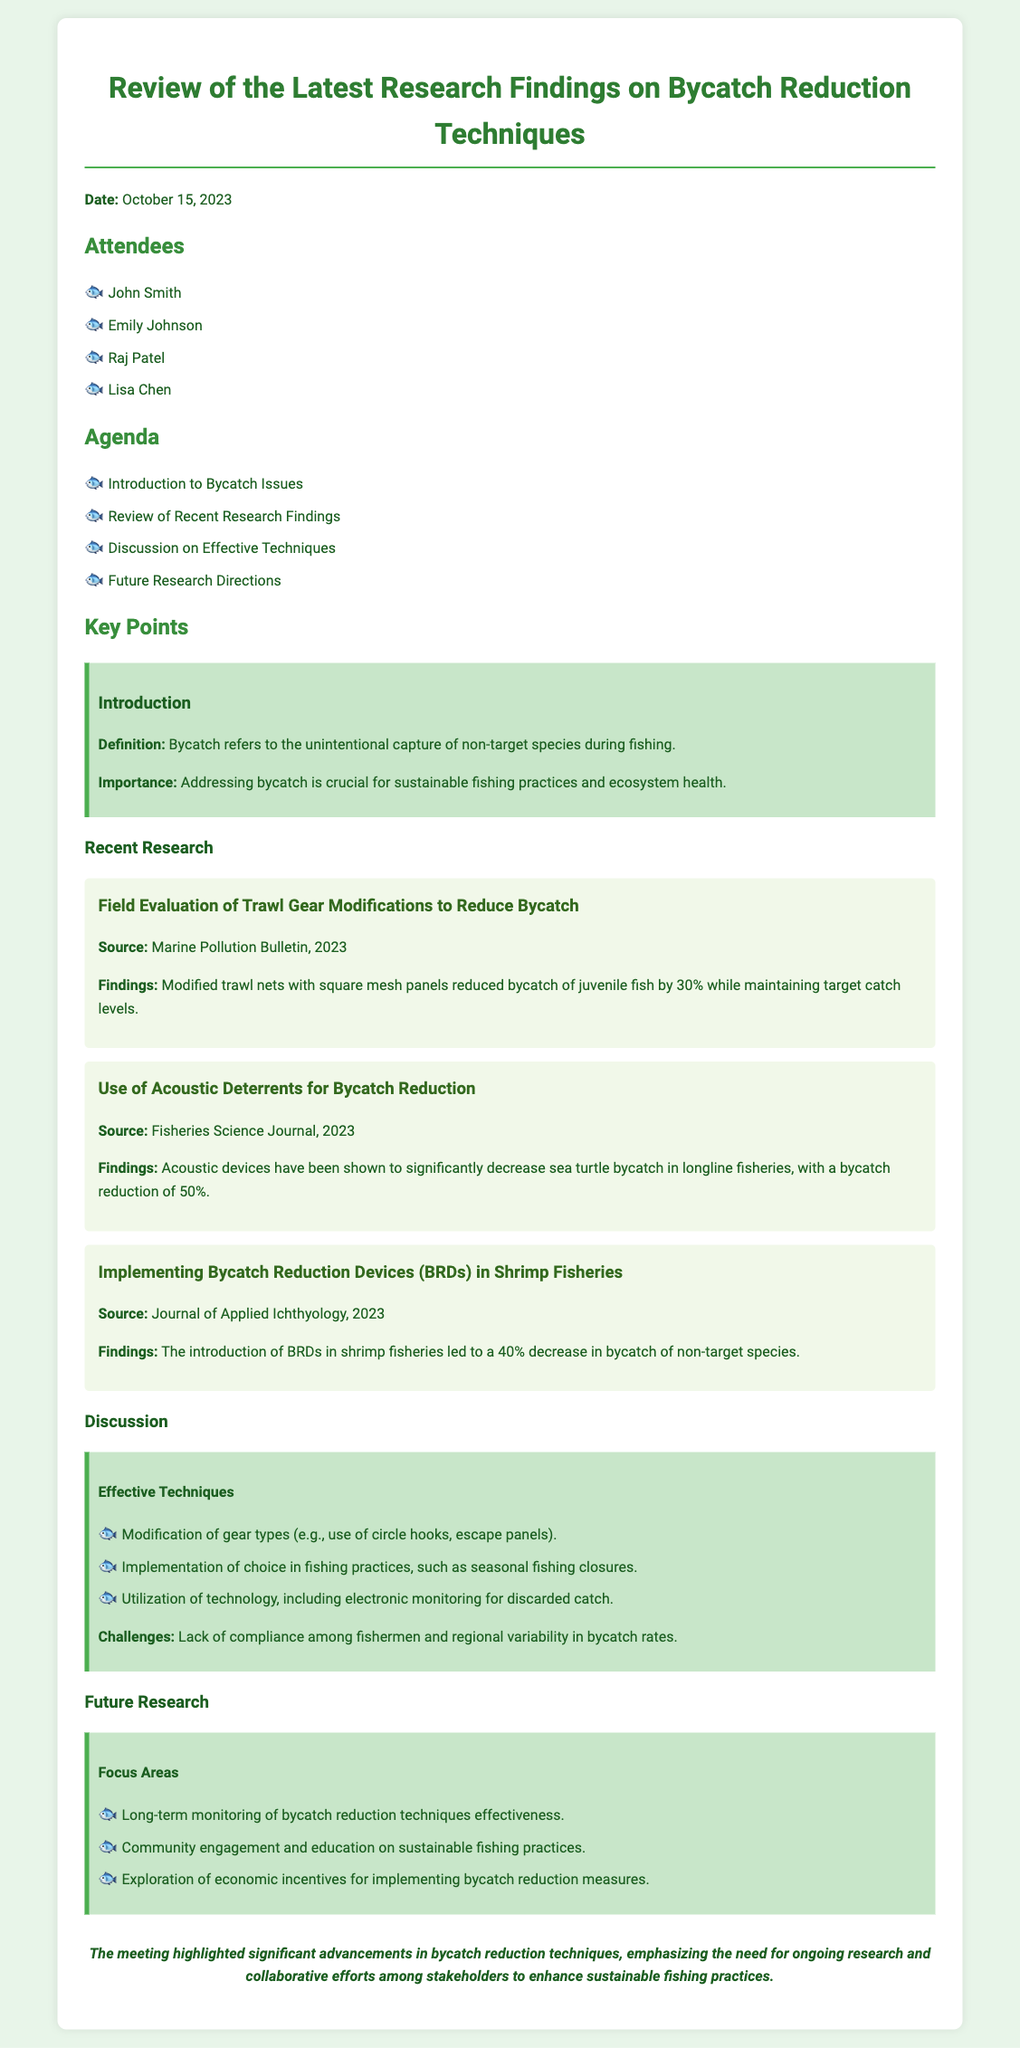What is the date of the meeting? The date of the meeting is clearly stated at the beginning of the document as October 15, 2023.
Answer: October 15, 2023 Who is one of the attendees at the meeting? The document lists the names of attendees; for example, John Smith is mentioned as one of them.
Answer: John Smith What percentage did the modified trawl nets reduce bycatch of juvenile fish? The findings from the research show a specific percentage reduction of 30% in juvenile fish bycatch from the modified trawl nets.
Answer: 30% What is one challenge mentioned in the discussion about bycatch reduction techniques? The document highlights that a key challenge is the lack of compliance among fishermen.
Answer: Lack of compliance What is one of the focus areas for future research? The document notes that one focus area for future research is long-term monitoring of bycatch reduction techniques effectiveness.
Answer: Long-term monitoring 